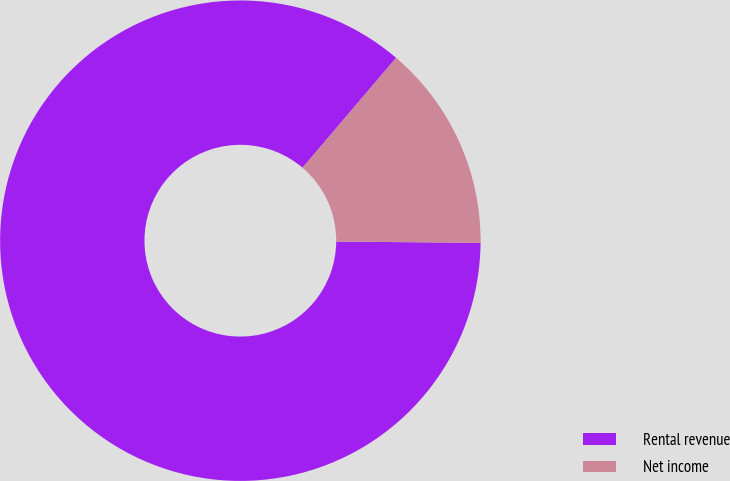Convert chart. <chart><loc_0><loc_0><loc_500><loc_500><pie_chart><fcel>Rental revenue<fcel>Net income<nl><fcel>86.09%<fcel>13.91%<nl></chart> 